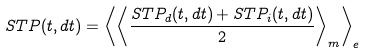Convert formula to latex. <formula><loc_0><loc_0><loc_500><loc_500>S T P ( t , d t ) = \left \langle \left \langle \frac { S T P _ { d } ( t , d t ) + S T P _ { i } ( t , d t ) } { 2 } \right \rangle _ { m } \right \rangle _ { e }</formula> 